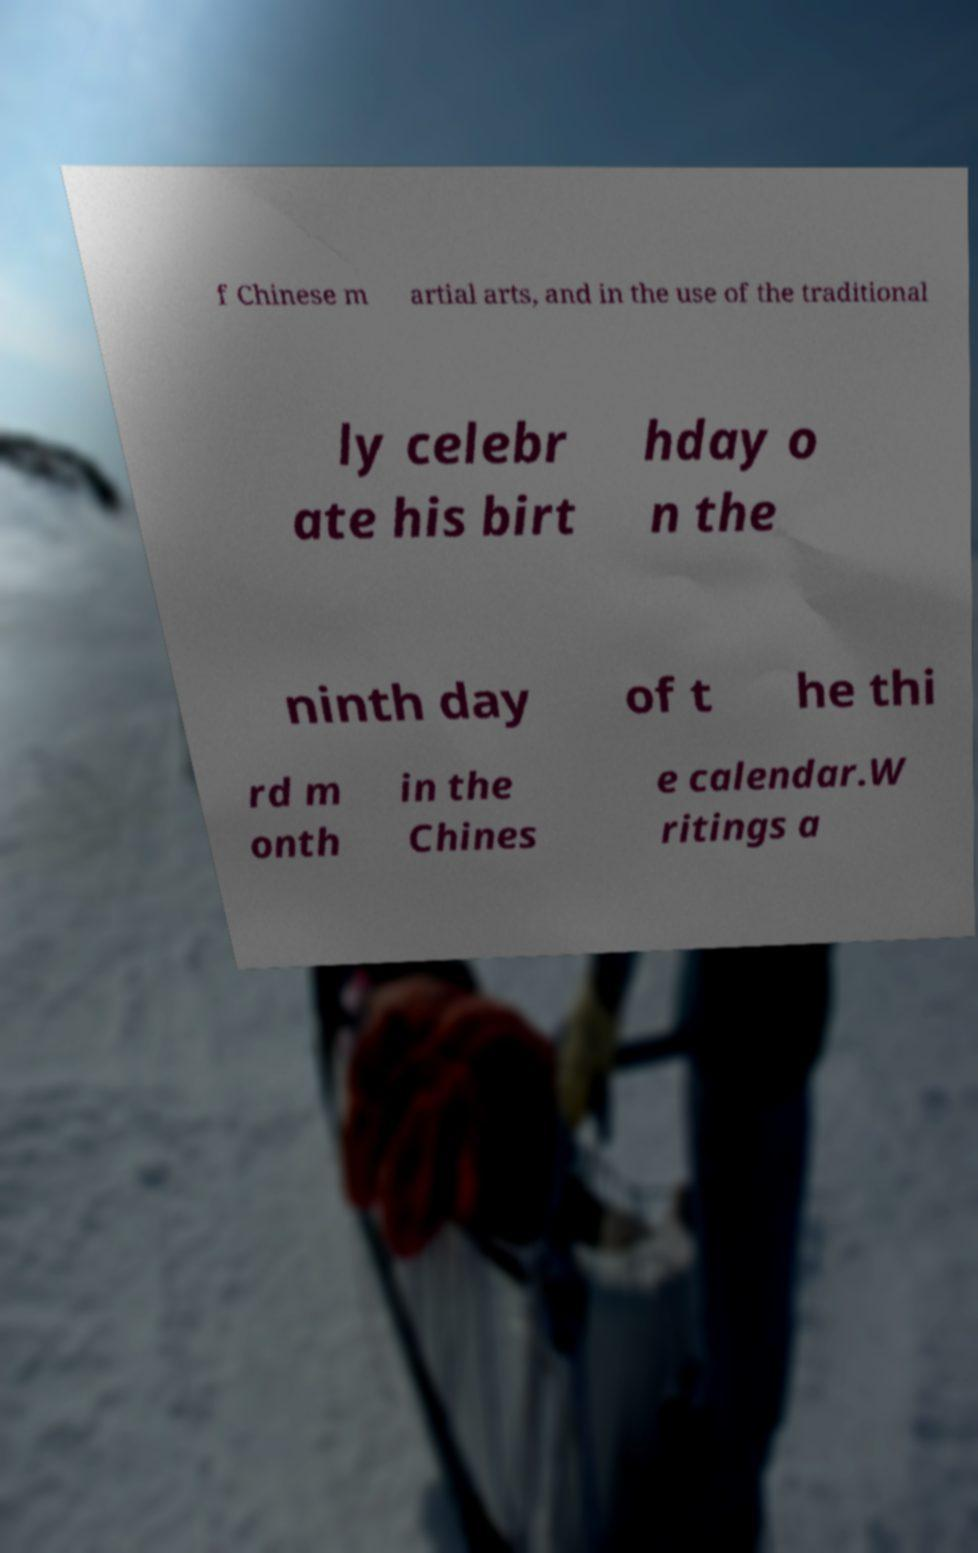Could you extract and type out the text from this image? f Chinese m artial arts, and in the use of the traditional ly celebr ate his birt hday o n the ninth day of t he thi rd m onth in the Chines e calendar.W ritings a 